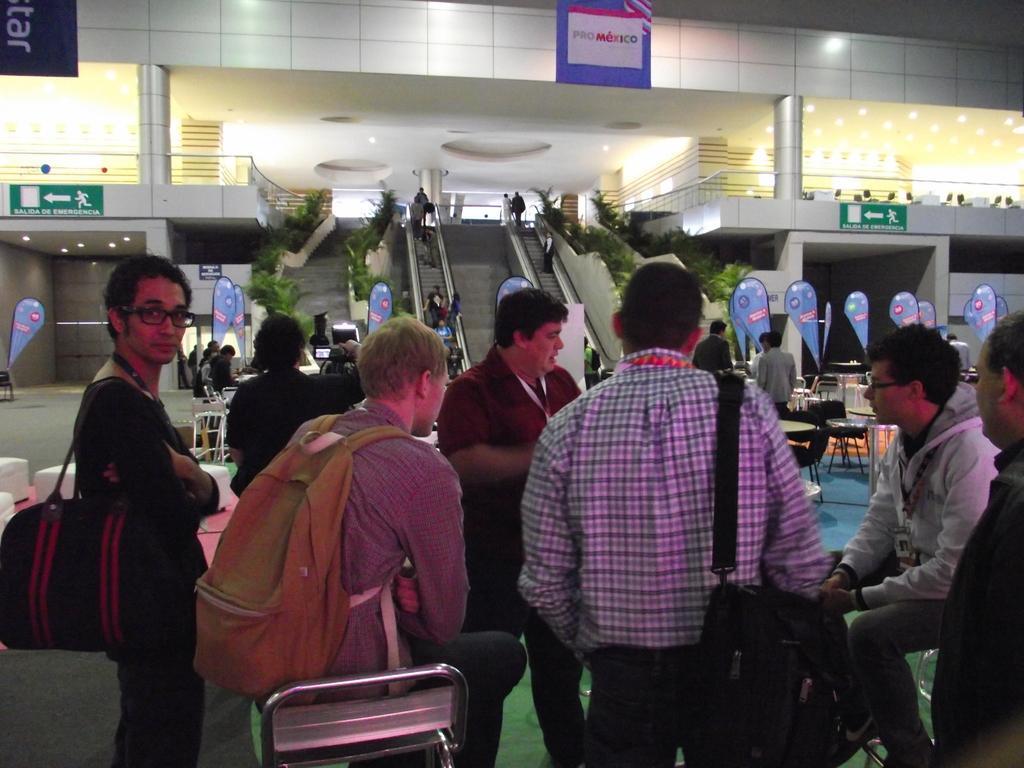How would you summarize this image in a sentence or two? This 3 person wore bag. This 2 persons are sitting. Far there are escalators. Beside this escalators there are plants. This is a sign board. Far there are chairs and tables. 